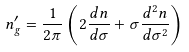Convert formula to latex. <formula><loc_0><loc_0><loc_500><loc_500>n _ { g } ^ { \prime } = \frac { 1 } { 2 \pi } \left ( 2 \frac { d n } { d \sigma } + \sigma \frac { d ^ { 2 } n } { d \sigma ^ { 2 } } \right )</formula> 